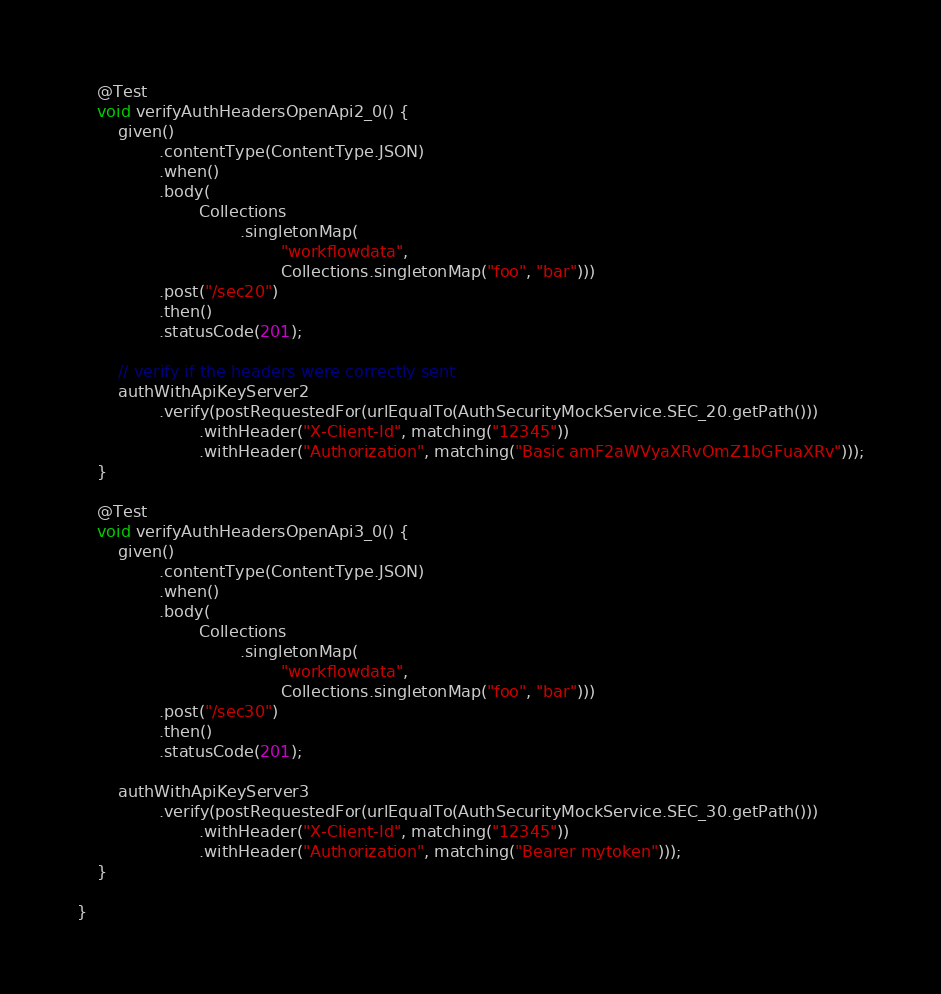<code> <loc_0><loc_0><loc_500><loc_500><_Java_>    @Test
    void verifyAuthHeadersOpenApi2_0() {
        given()
                .contentType(ContentType.JSON)
                .when()
                .body(
                        Collections
                                .singletonMap(
                                        "workflowdata",
                                        Collections.singletonMap("foo", "bar")))
                .post("/sec20")
                .then()
                .statusCode(201);

        // verify if the headers were correctly sent
        authWithApiKeyServer2
                .verify(postRequestedFor(urlEqualTo(AuthSecurityMockService.SEC_20.getPath()))
                        .withHeader("X-Client-Id", matching("12345"))
                        .withHeader("Authorization", matching("Basic amF2aWVyaXRvOmZ1bGFuaXRv")));
    }

    @Test
    void verifyAuthHeadersOpenApi3_0() {
        given()
                .contentType(ContentType.JSON)
                .when()
                .body(
                        Collections
                                .singletonMap(
                                        "workflowdata",
                                        Collections.singletonMap("foo", "bar")))
                .post("/sec30")
                .then()
                .statusCode(201);

        authWithApiKeyServer3
                .verify(postRequestedFor(urlEqualTo(AuthSecurityMockService.SEC_30.getPath()))
                        .withHeader("X-Client-Id", matching("12345"))
                        .withHeader("Authorization", matching("Bearer mytoken")));
    }

}
</code> 